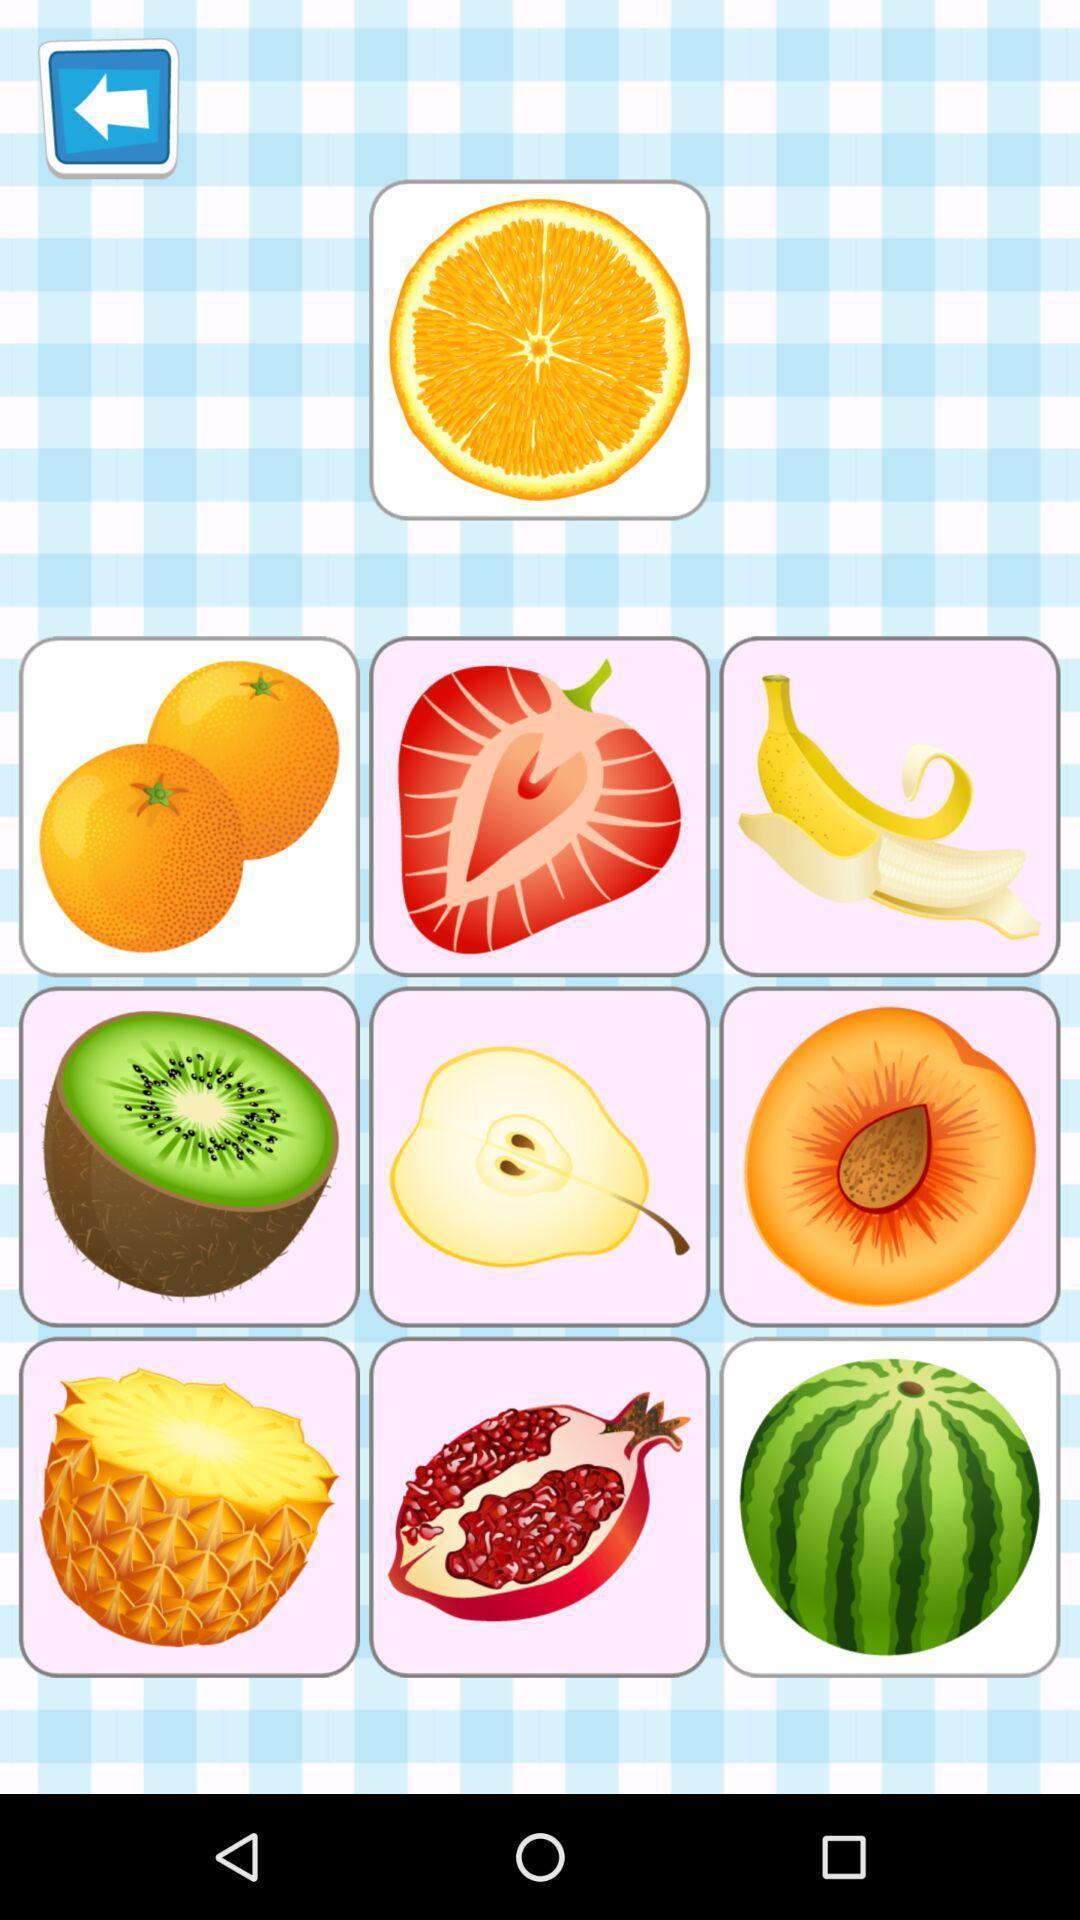Describe the content in this image. Page showing fruits pictures in an game application. 